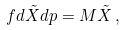<formula> <loc_0><loc_0><loc_500><loc_500>\ f { d \tilde { X } } { d p } = M \tilde { X } \, ,</formula> 